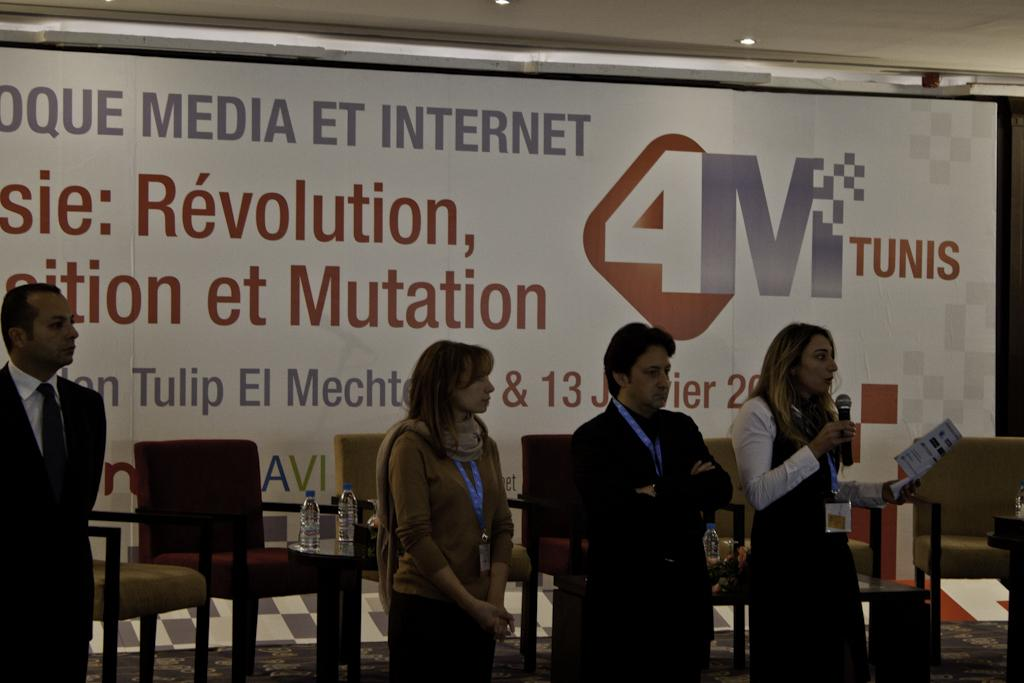What is happening in the image? There are people standing in the image. Can you describe what the woman is holding in her hands? The woman is holding a paper and a mic in her hands. What type of structure is visible in the background of the image? There is no structure visible in the background of the image. What is the color of the woman's neck in the image? The color of the woman's neck cannot be determined from the image, as it does not provide information about the color of her skin or clothing. 